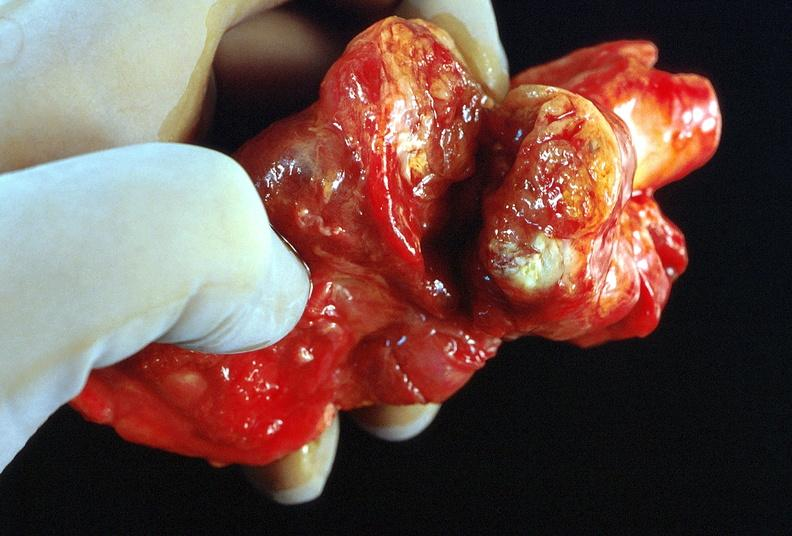s adenocarcinoma present?
Answer the question using a single word or phrase. No 